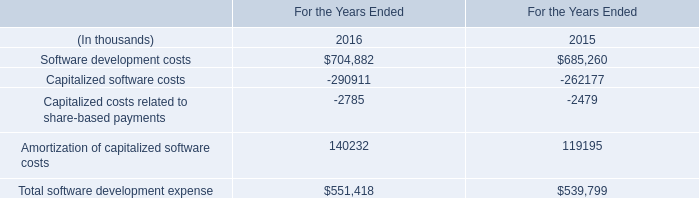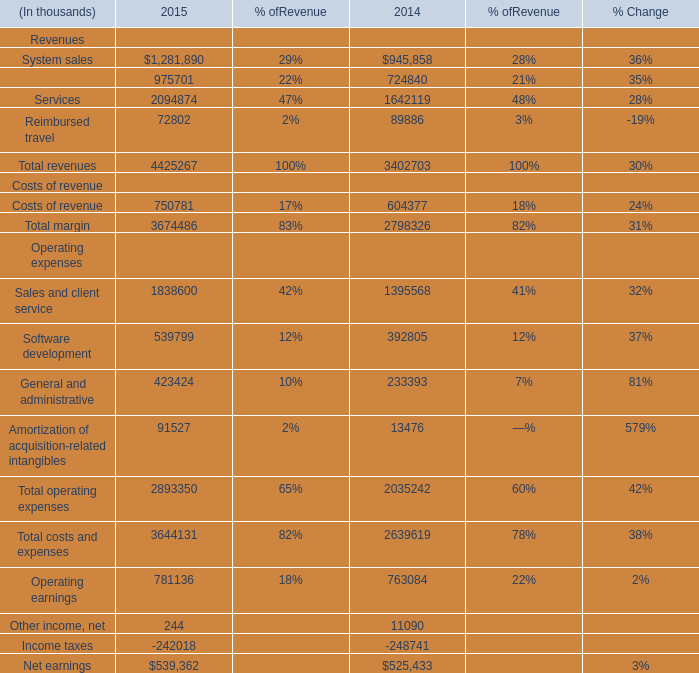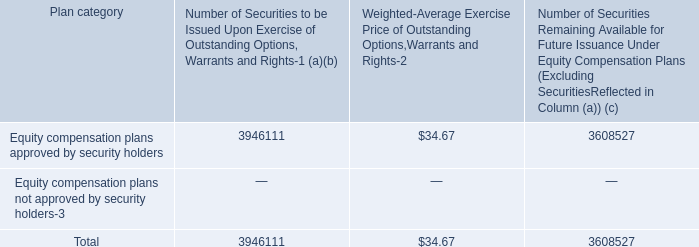What is the ratio of Services in Table 1 to the Amortization of capitalized software costs in Table 0 in 2015? 
Computations: (2094874 / 119195)
Answer: 17.57518. 